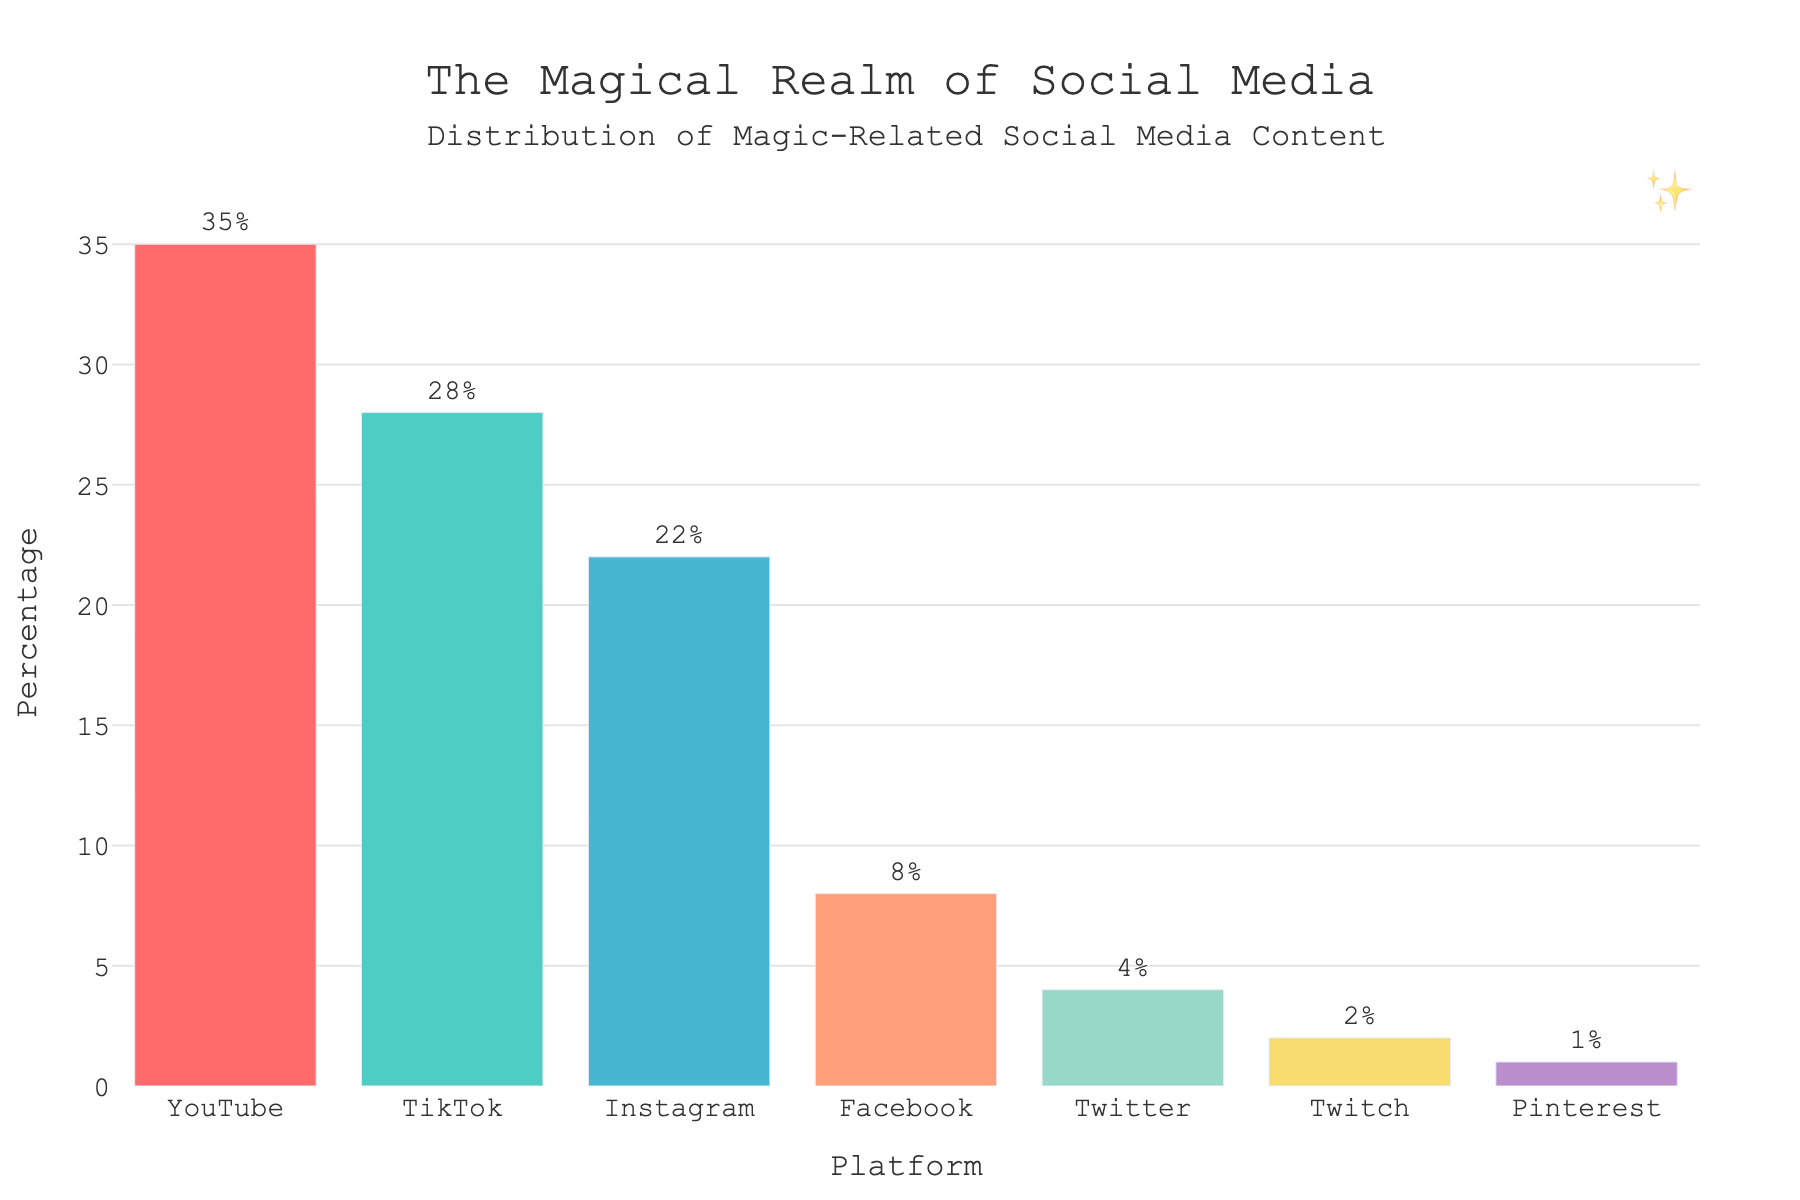Which platform has the highest percentage of magic-related social media content? To find the highest percentage, compare the percentages of all the platforms listed. YouTube has the highest percentage at 35%.
Answer: YouTube What is the combined percentage of magic-related content for Instagram and TikTok? Sum the percentages of Instagram and TikTok, which are 22% and 28%, respectively. The combined percentage is 22% + 28% = 50%.
Answer: 50% How much higher is YouTube's percentage compared to Facebook's? Subtract Facebook's percentage from YouTube's percentage. YouTube is at 35%, and Facebook is at 8%, so 35% - 8% = 27%.
Answer: 27% Which platform has the lowest percentage of magic-related social media content? Identify the platform with the smallest percentage value. Pinterest has the lowest percentage at 1%.
Answer: Pinterest By how much does TikTok's percentage exceed Twitter's percentage? Subtract Twitter's percentage from TikTok's percentage. TikTok is at 28%, and Twitter is at 4%, so 28% - 4% = 24%.
Answer: 24% What is the average percentage of magic-related social media content across all platforms? To find the average percentage, sum all the percentages and divide by the number of platforms. The total sum is 35% + 28% + 22% + 8% + 4% + 2% + 1% = 100%. There are 7 platforms, so the average is 100% / 7 ≈ 14.29%.
Answer: 14.29% How much more content does YouTube have compared to TikTok in terms of percentage? Subtract TikTok's percentage from YouTube's percentage. YouTube is at 35%, and TikTok is at 28%, so 35% - 28% = 7%.
Answer: 7% If you combine the percentage for YouTube, TikTok, and Instagram, what proportion of the total data does it represent? Sum the percentages for YouTube, TikTok, and Instagram, which is 35% + 28% + 22% = 85%. Thus, these three platforms represent 85% of the total data.
Answer: 85% What is the difference between the percentage of magic content on Instagram and the average percentage across all platforms? First, calculate the average percentage as 14.29%. Then, subtract the average from Instagram's percentage. Instagram has 22%, so 22% - 14.29% ≈ 7.71%.
Answer: 7.71% Which platform occupies the middle position in terms of percentage when sorted in descending order? Order the platforms by percentage values in descending order: YouTube (35%), TikTok (28%), Instagram (22%), Facebook (8%), Twitter (4%), Twitch (2%), Pinterest (1%). The middle position is Facebook with 8%.
Answer: Facebook 